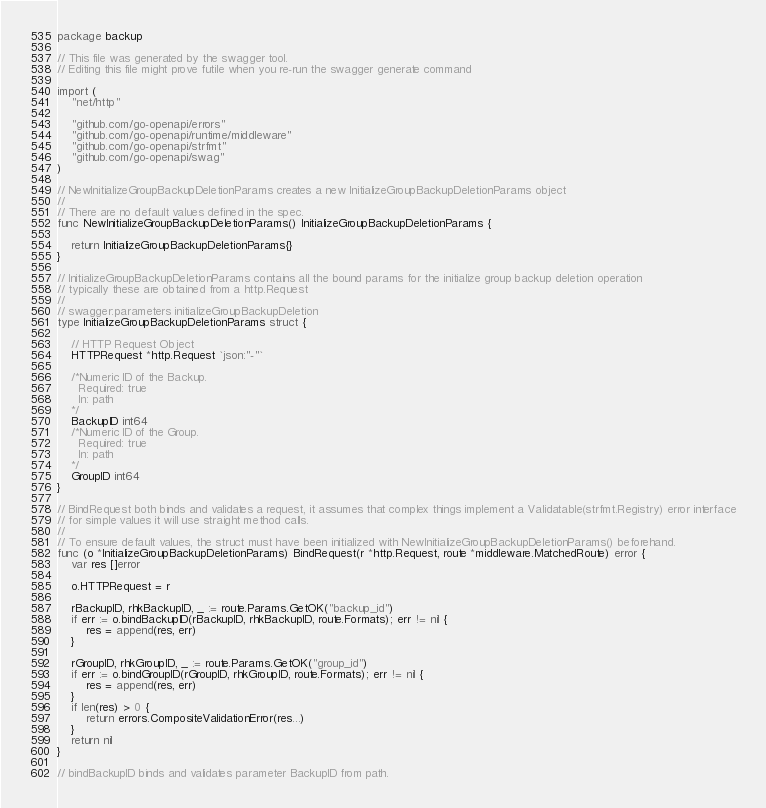<code> <loc_0><loc_0><loc_500><loc_500><_Go_>package backup

// This file was generated by the swagger tool.
// Editing this file might prove futile when you re-run the swagger generate command

import (
	"net/http"

	"github.com/go-openapi/errors"
	"github.com/go-openapi/runtime/middleware"
	"github.com/go-openapi/strfmt"
	"github.com/go-openapi/swag"
)

// NewInitializeGroupBackupDeletionParams creates a new InitializeGroupBackupDeletionParams object
//
// There are no default values defined in the spec.
func NewInitializeGroupBackupDeletionParams() InitializeGroupBackupDeletionParams {

	return InitializeGroupBackupDeletionParams{}
}

// InitializeGroupBackupDeletionParams contains all the bound params for the initialize group backup deletion operation
// typically these are obtained from a http.Request
//
// swagger:parameters initializeGroupBackupDeletion
type InitializeGroupBackupDeletionParams struct {

	// HTTP Request Object
	HTTPRequest *http.Request `json:"-"`

	/*Numeric ID of the Backup.
	  Required: true
	  In: path
	*/
	BackupID int64
	/*Numeric ID of the Group.
	  Required: true
	  In: path
	*/
	GroupID int64
}

// BindRequest both binds and validates a request, it assumes that complex things implement a Validatable(strfmt.Registry) error interface
// for simple values it will use straight method calls.
//
// To ensure default values, the struct must have been initialized with NewInitializeGroupBackupDeletionParams() beforehand.
func (o *InitializeGroupBackupDeletionParams) BindRequest(r *http.Request, route *middleware.MatchedRoute) error {
	var res []error

	o.HTTPRequest = r

	rBackupID, rhkBackupID, _ := route.Params.GetOK("backup_id")
	if err := o.bindBackupID(rBackupID, rhkBackupID, route.Formats); err != nil {
		res = append(res, err)
	}

	rGroupID, rhkGroupID, _ := route.Params.GetOK("group_id")
	if err := o.bindGroupID(rGroupID, rhkGroupID, route.Formats); err != nil {
		res = append(res, err)
	}
	if len(res) > 0 {
		return errors.CompositeValidationError(res...)
	}
	return nil
}

// bindBackupID binds and validates parameter BackupID from path.</code> 